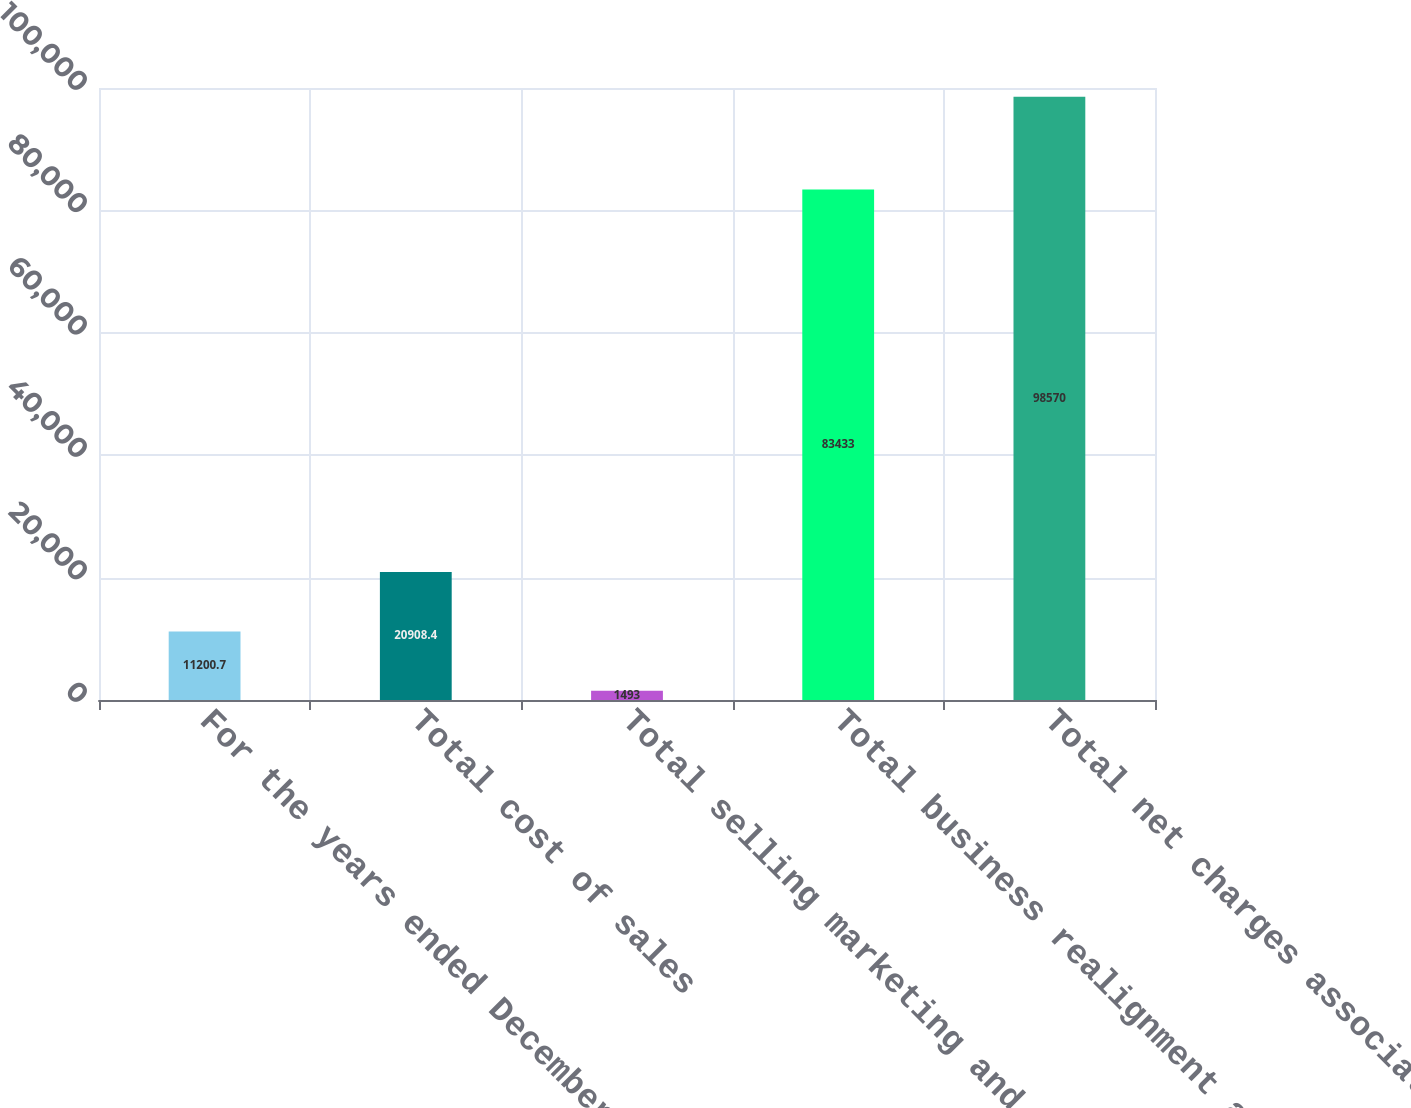Convert chart to OTSL. <chart><loc_0><loc_0><loc_500><loc_500><bar_chart><fcel>For the years ended December<fcel>Total cost of sales<fcel>Total selling marketing and<fcel>Total business realignment and<fcel>Total net charges associated<nl><fcel>11200.7<fcel>20908.4<fcel>1493<fcel>83433<fcel>98570<nl></chart> 